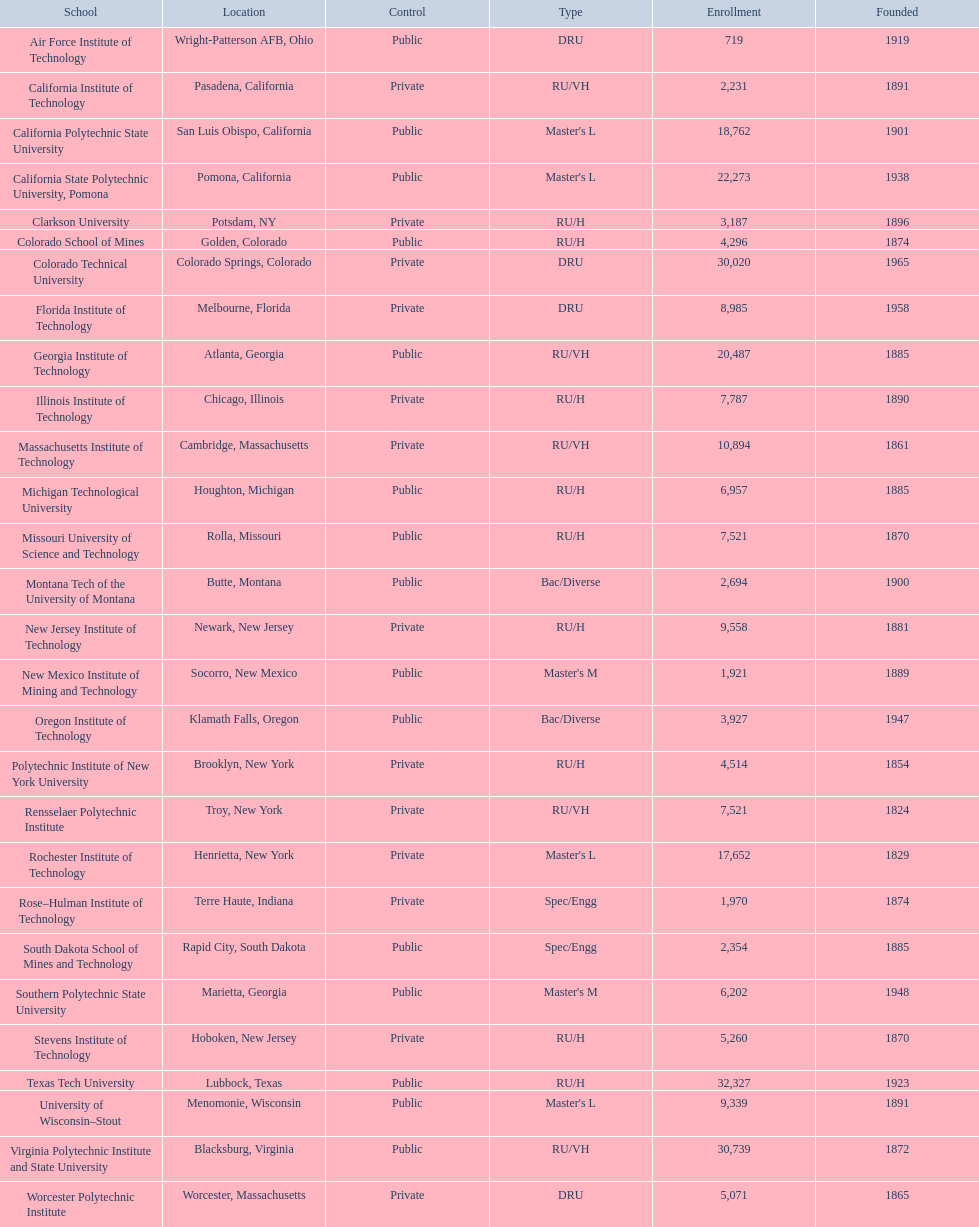What is the number of us technological schools in the state of california? 3. 